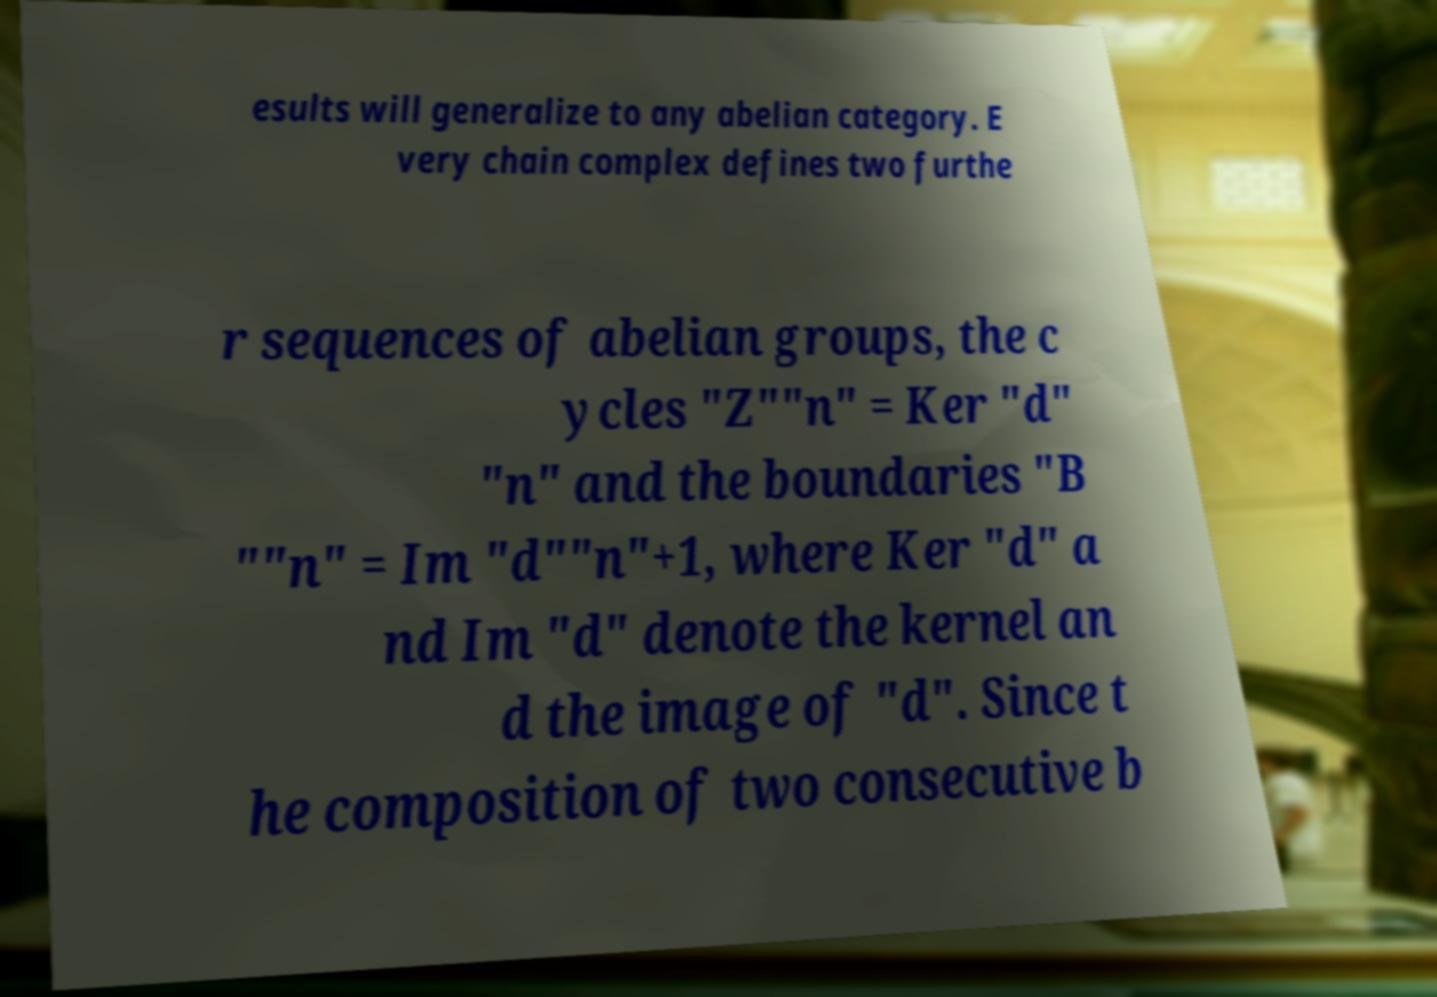For documentation purposes, I need the text within this image transcribed. Could you provide that? esults will generalize to any abelian category. E very chain complex defines two furthe r sequences of abelian groups, the c ycles "Z""n" = Ker "d" "n" and the boundaries "B ""n" = Im "d""n"+1, where Ker "d" a nd Im "d" denote the kernel an d the image of "d". Since t he composition of two consecutive b 